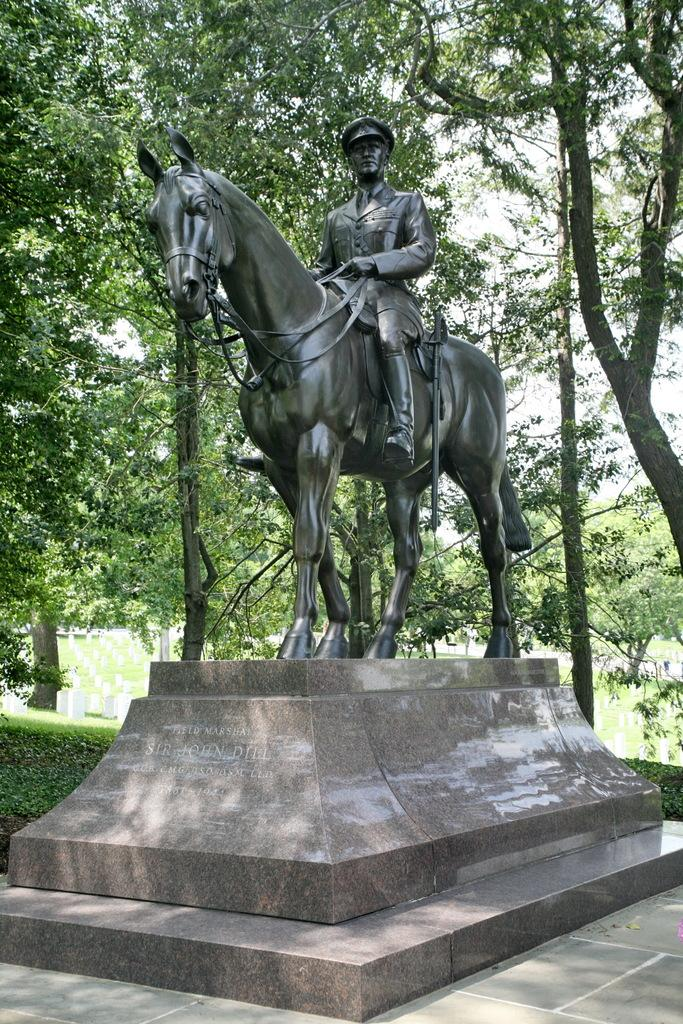What is the main subject of the image? There is a statue of a person sitting on a horse in the image. What can be seen in the background of the image? There are headstones and trees in the background of the image. What is visible above the headstones and trees? The sky is visible in the background of the image. Where is the shelf located in the image? There is no shelf present in the image. How many rabbits can be seen in the image? There are no rabbits present in the image. 